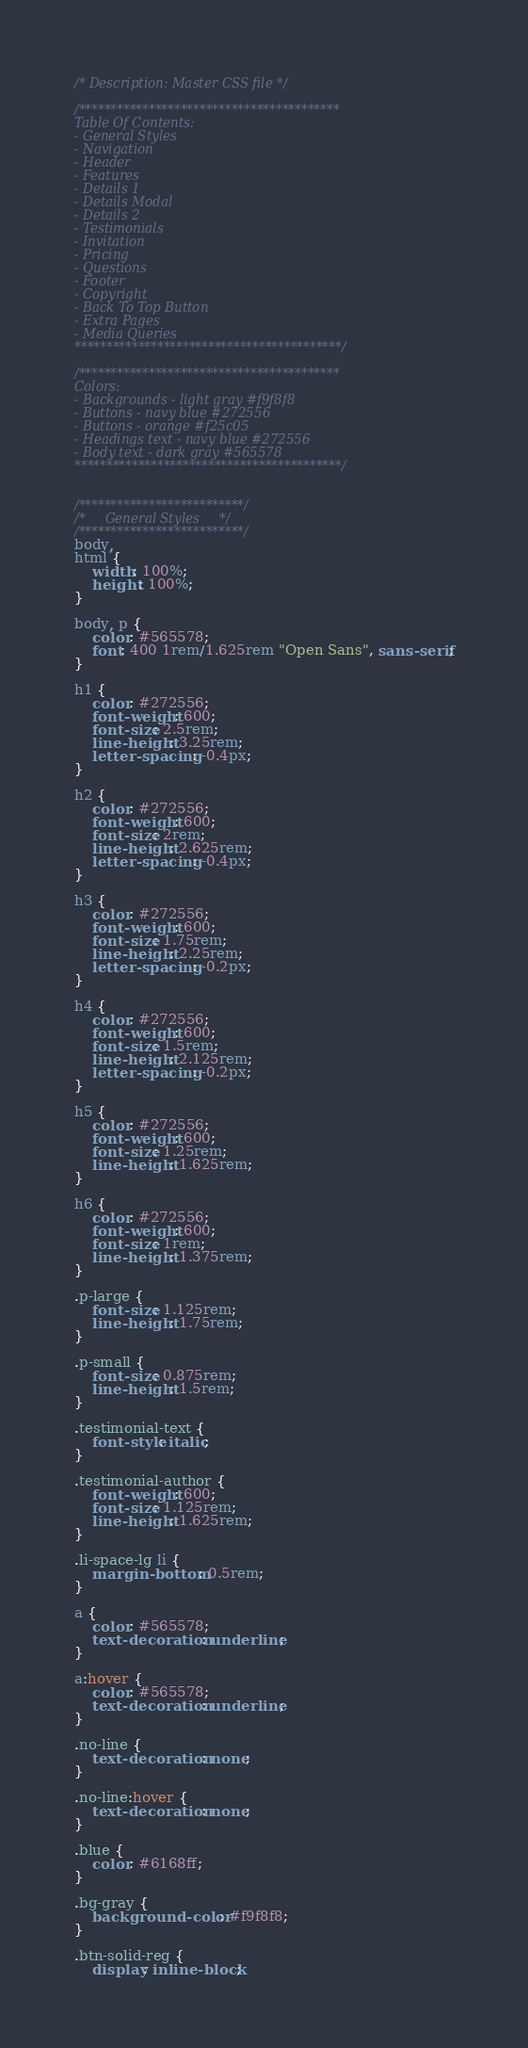<code> <loc_0><loc_0><loc_500><loc_500><_CSS_>/* Description: Master CSS file */

/*****************************************
Table Of Contents:
- General Styles
- Navigation
- Header
- Features
- Details 1
- Details Modal
- Details 2
- Testimonials
- Invitation
- Pricing
- Questions
- Footer
- Copyright
- Back To Top Button
- Extra Pages
- Media Queries
******************************************/

/*****************************************
Colors:
- Backgrounds - light gray #f9f8f8
- Buttons - navy blue #272556
- Buttons - orange #f25c05
- Headings text - navy blue #272556
- Body text - dark gray #565578
******************************************/


/**************************/
/*     General Styles     */
/**************************/
body,
html {
    width: 100%;
	height: 100%;
}

body, p {
	color: #565578; 
	font: 400 1rem/1.625rem "Open Sans", sans-serif;
}

h1 {
	color: #272556;
	font-weight: 600;
	font-size: 2.5rem;
	line-height: 3.25rem;
	letter-spacing: -0.4px;
}

h2 {
	color: #272556;
	font-weight: 600;
	font-size: 2rem;
	line-height: 2.625rem;
	letter-spacing: -0.4px;
}

h3 {
	color: #272556;
	font-weight: 600;
	font-size: 1.75rem;
	line-height: 2.25rem;
	letter-spacing: -0.2px;
}

h4 {
	color: #272556;
	font-weight: 600;
	font-size: 1.5rem;
	line-height: 2.125rem;
	letter-spacing: -0.2px;
}

h5 {
	color: #272556;
	font-weight: 600;
	font-size: 1.25rem;
	line-height: 1.625rem;
}

h6 {
	color: #272556;
	font-weight: 600;
	font-size: 1rem;
	line-height: 1.375rem;
}

.p-large {
	font-size: 1.125rem;
	line-height: 1.75rem;
}

.p-small {
	font-size: 0.875rem;
	line-height: 1.5rem;
}

.testimonial-text {
	font-style: italic;
}

.testimonial-author {
	font-weight: 600;
	font-size: 1.125rem;
	line-height: 1.625rem;
}

.li-space-lg li {
	margin-bottom: 0.5rem;
}

a {
	color: #565578;
	text-decoration: underline;
}

a:hover {
	color: #565578;
	text-decoration: underline;
}

.no-line {
	text-decoration: none;
}

.no-line:hover {
	text-decoration: none;
}

.blue {
	color: #6168ff;
}

.bg-gray {
	background-color: #f9f8f8;
}

.btn-solid-reg {
	display: inline-block;</code> 